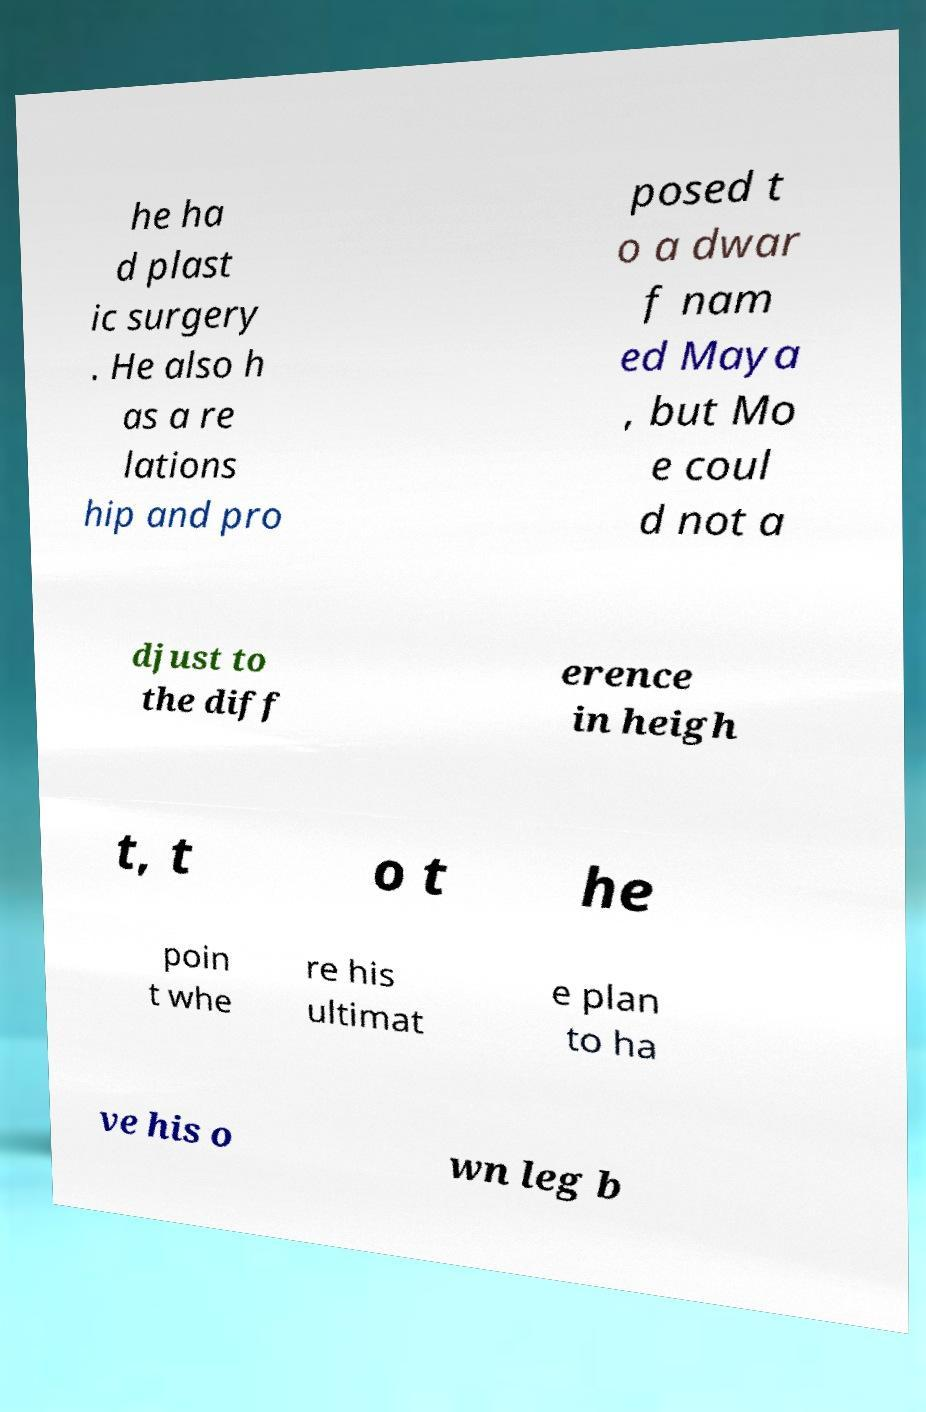Please identify and transcribe the text found in this image. he ha d plast ic surgery . He also h as a re lations hip and pro posed t o a dwar f nam ed Maya , but Mo e coul d not a djust to the diff erence in heigh t, t o t he poin t whe re his ultimat e plan to ha ve his o wn leg b 